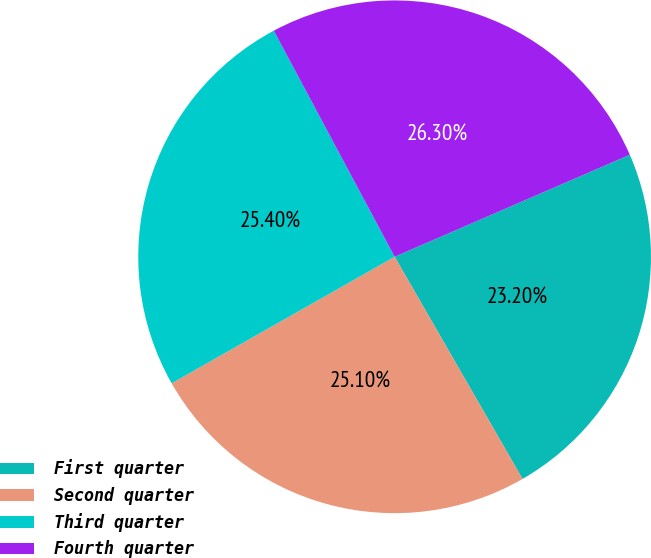Convert chart to OTSL. <chart><loc_0><loc_0><loc_500><loc_500><pie_chart><fcel>First quarter<fcel>Second quarter<fcel>Third quarter<fcel>Fourth quarter<nl><fcel>23.2%<fcel>25.1%<fcel>25.4%<fcel>26.3%<nl></chart> 